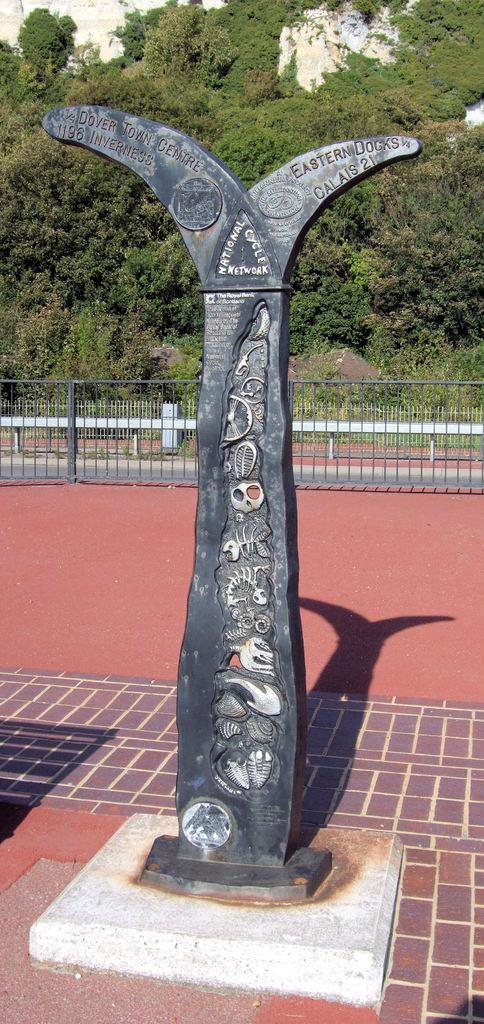What is the main subject in the image? There is a statue in the image. What can be seen on the statue? The statue has text on it. How is the statue positioned in the image? The statue is placed on the ground. What other elements can be seen in the background of the image? There is a barricade, a bench, and a group of trees in the background of the image. Can you tell me how many basketballs are placed on the statue in the image? There are no basketballs present on the statue in the image. Is there a goat standing next to the statue in the image? There is no goat present in the image. 